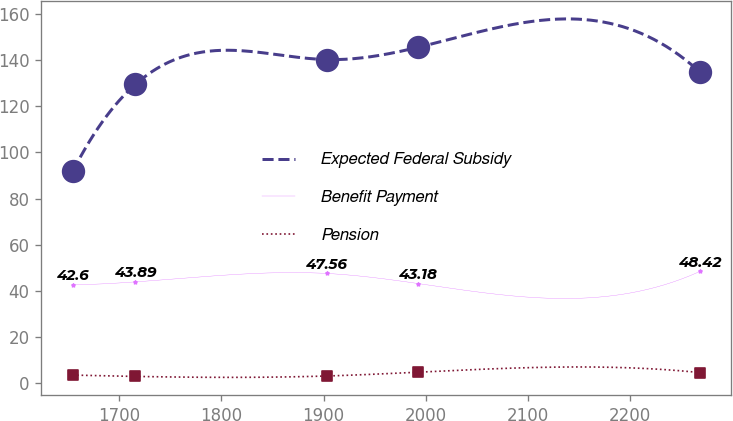Convert chart. <chart><loc_0><loc_0><loc_500><loc_500><line_chart><ecel><fcel>Expected Federal Subsidy<fcel>Benefit Payment<fcel>Pension<nl><fcel>1654.4<fcel>91.78<fcel>42.6<fcel>3.5<nl><fcel>1715.81<fcel>129.51<fcel>43.89<fcel>2.92<nl><fcel>1902.94<fcel>140.25<fcel>47.56<fcel>3.1<nl><fcel>1992.57<fcel>145.56<fcel>43.18<fcel>4.76<nl><fcel>2268.5<fcel>134.82<fcel>48.42<fcel>4.58<nl></chart> 